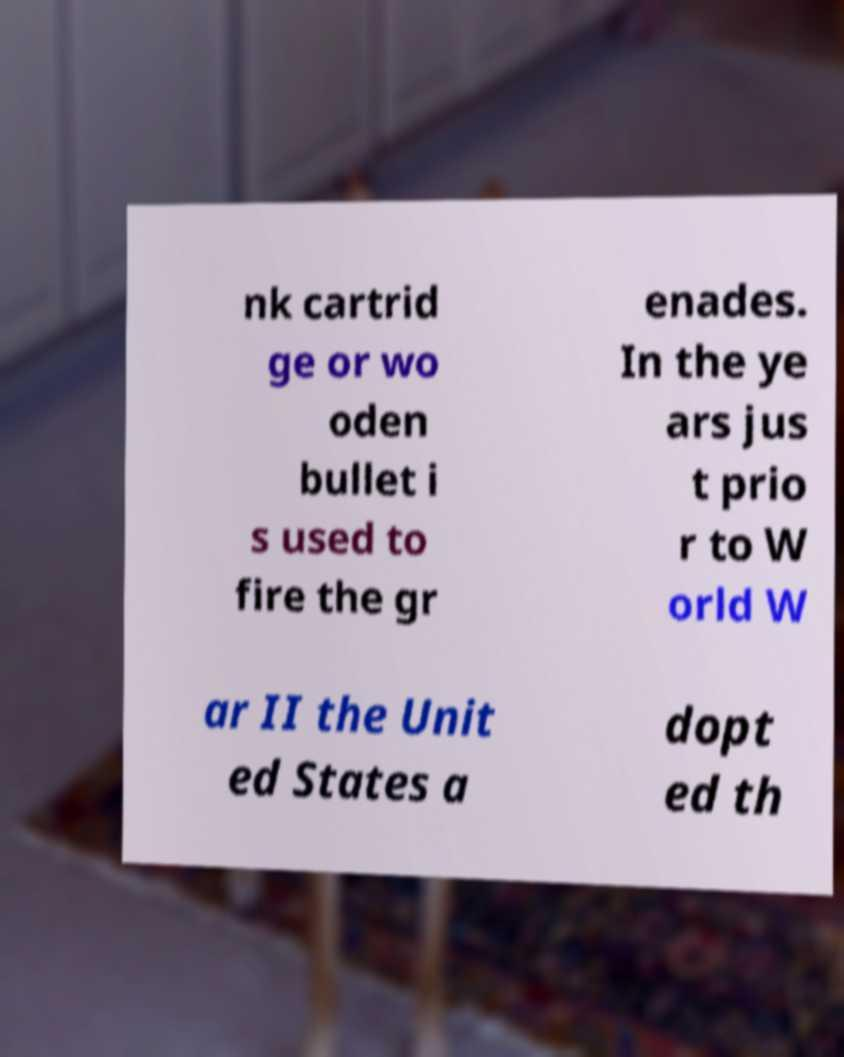Please identify and transcribe the text found in this image. nk cartrid ge or wo oden bullet i s used to fire the gr enades. In the ye ars jus t prio r to W orld W ar II the Unit ed States a dopt ed th 